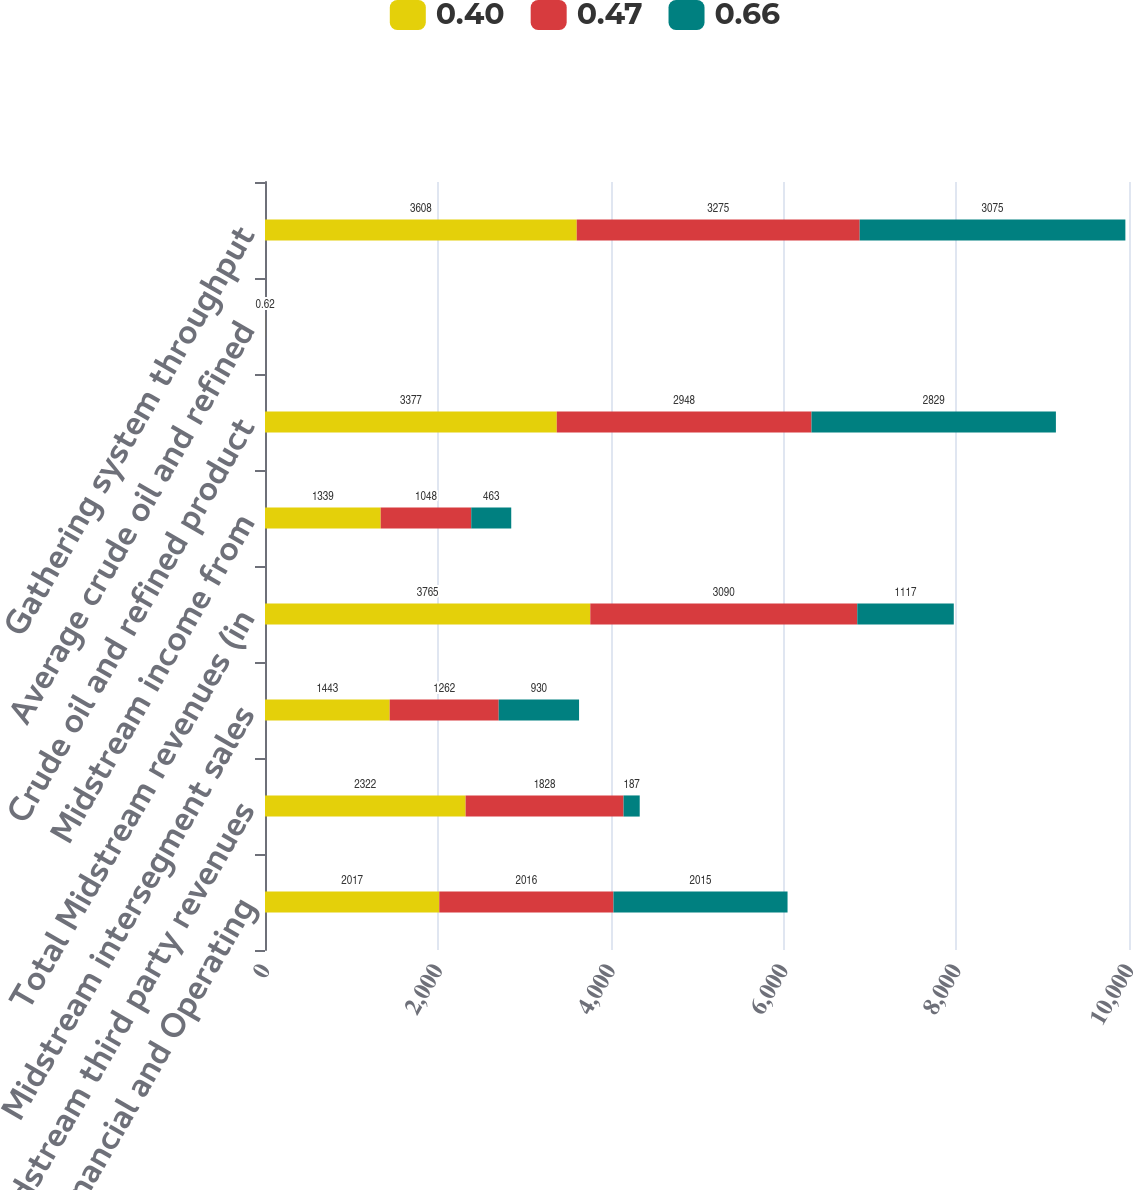Convert chart to OTSL. <chart><loc_0><loc_0><loc_500><loc_500><stacked_bar_chart><ecel><fcel>Key Financial and Operating<fcel>Midstream third party revenues<fcel>Midstream intersegment sales<fcel>Total Midstream revenues (in<fcel>Midstream income from<fcel>Crude oil and refined product<fcel>Average crude oil and refined<fcel>Gathering system throughput<nl><fcel>0.4<fcel>2017<fcel>2322<fcel>1443<fcel>3765<fcel>1339<fcel>3377<fcel>0.61<fcel>3608<nl><fcel>0.47<fcel>2016<fcel>1828<fcel>1262<fcel>3090<fcel>1048<fcel>2948<fcel>0.61<fcel>3275<nl><fcel>0.66<fcel>2015<fcel>187<fcel>930<fcel>1117<fcel>463<fcel>2829<fcel>0.62<fcel>3075<nl></chart> 